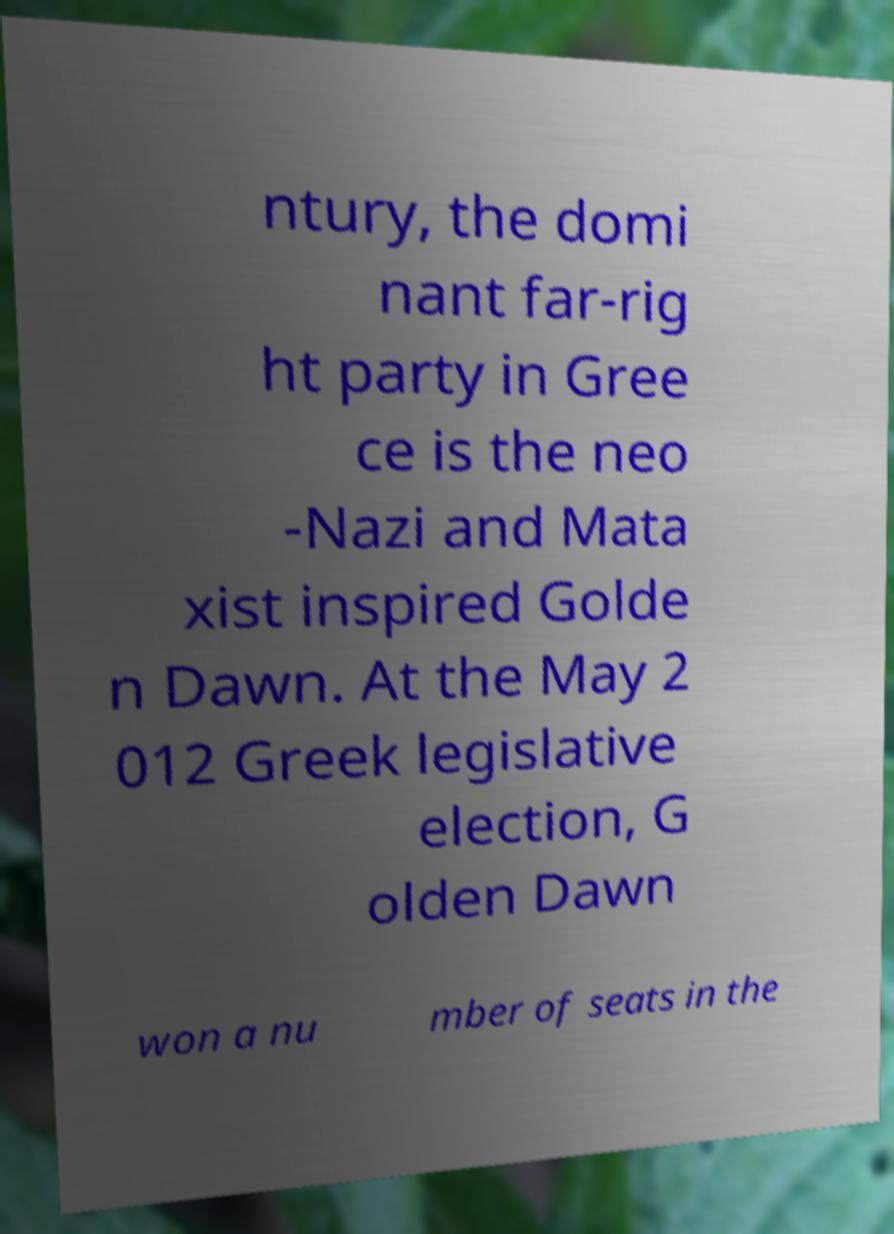Please read and relay the text visible in this image. What does it say? ntury, the domi nant far-rig ht party in Gree ce is the neo -Nazi and Mata xist inspired Golde n Dawn. At the May 2 012 Greek legislative election, G olden Dawn won a nu mber of seats in the 